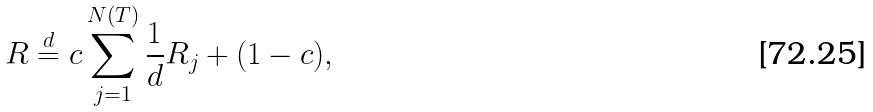Convert formula to latex. <formula><loc_0><loc_0><loc_500><loc_500>R \stackrel { d } = c \sum _ { j = 1 } ^ { N ( T ) } \frac { 1 } { d } R _ { j } + ( 1 - c ) ,</formula> 